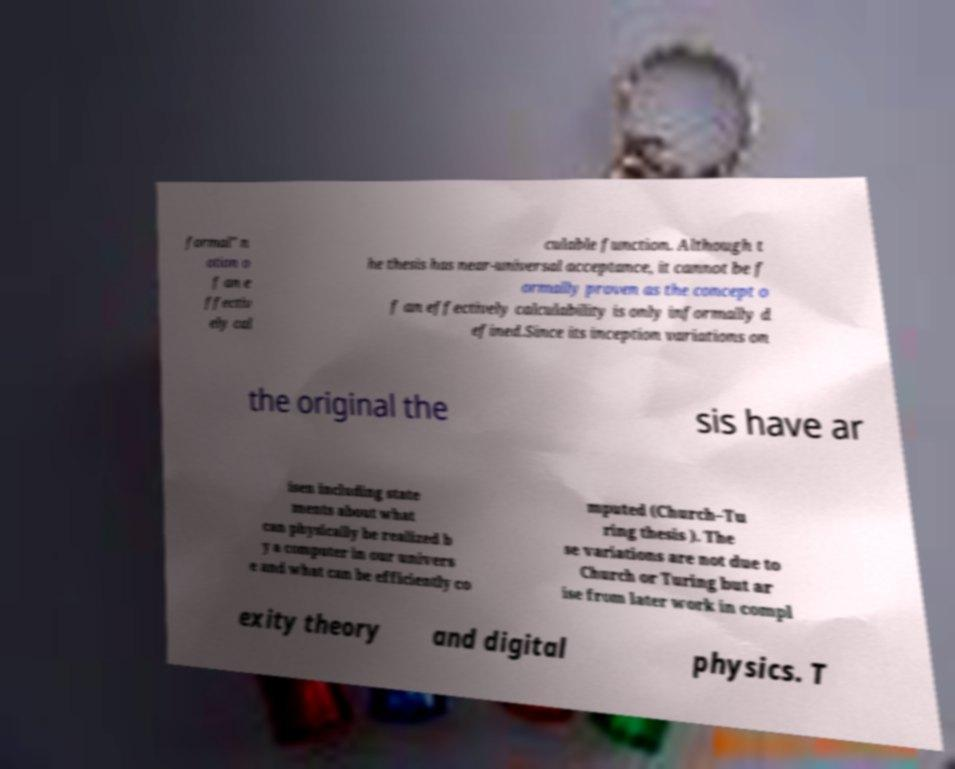Could you extract and type out the text from this image? formal" n otion o f an e ffectiv ely cal culable function. Although t he thesis has near-universal acceptance, it cannot be f ormally proven as the concept o f an effectively calculability is only informally d efined.Since its inception variations on the original the sis have ar isen including state ments about what can physically be realized b y a computer in our univers e and what can be efficiently co mputed (Church–Tu ring thesis ). The se variations are not due to Church or Turing but ar ise from later work in compl exity theory and digital physics. T 